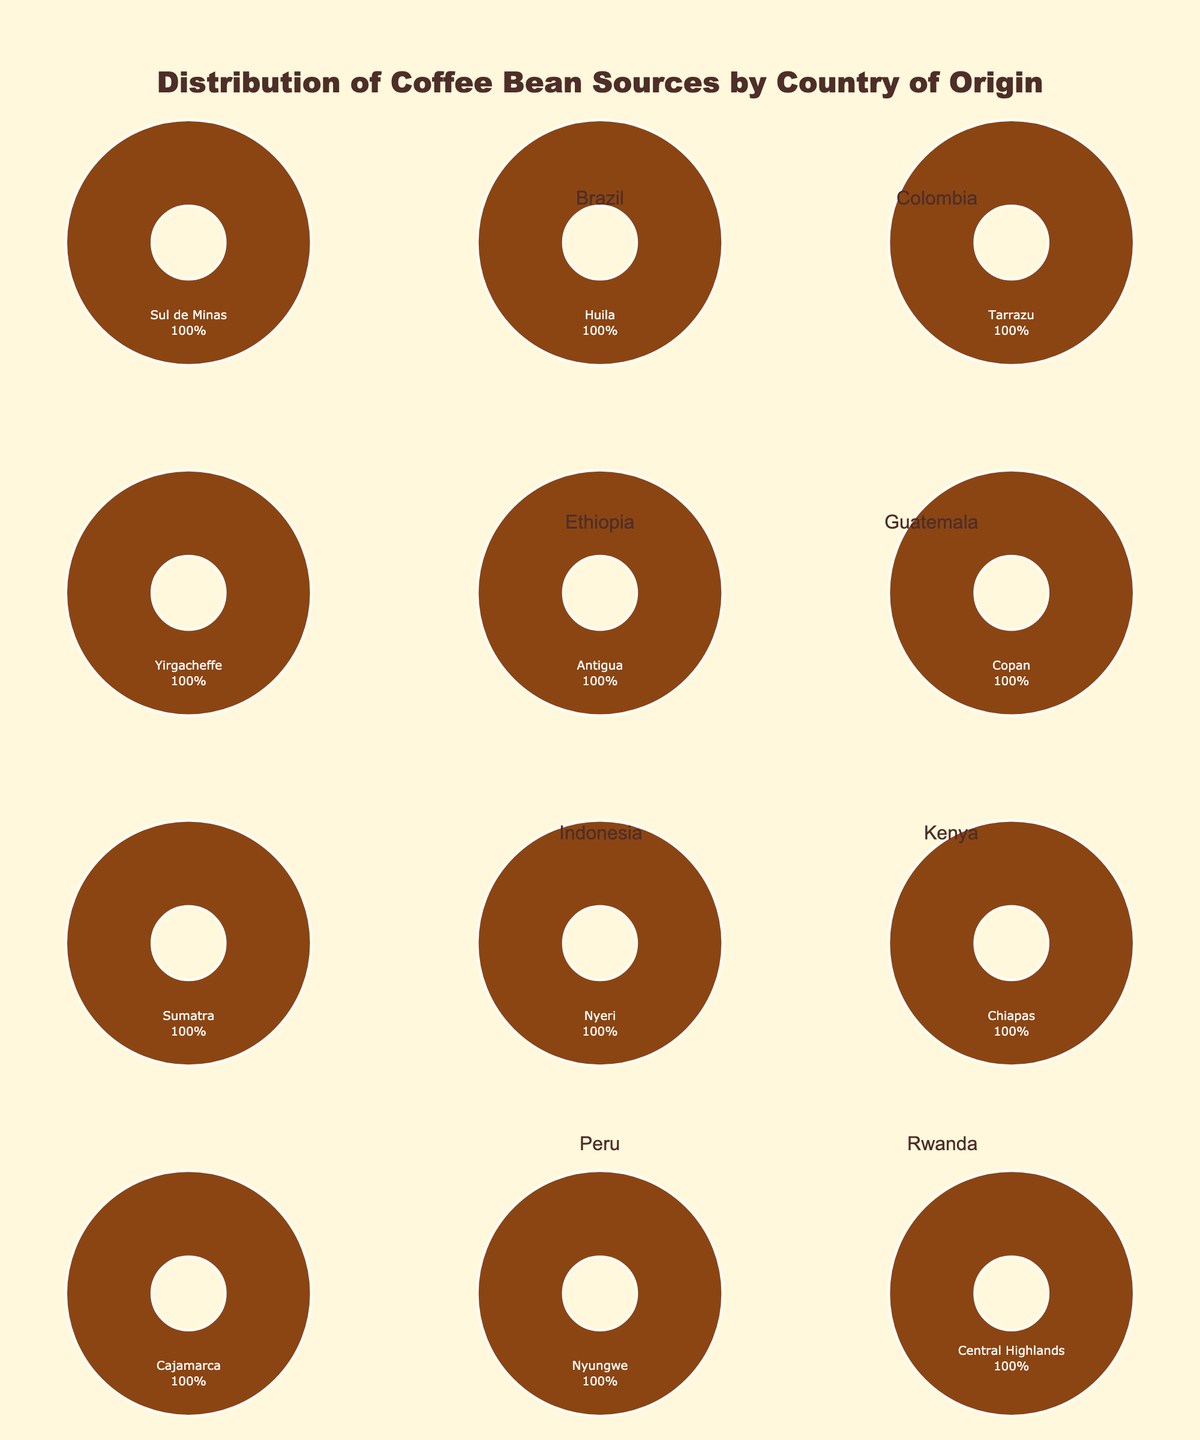Which country has the highest percentage of coffee beans sourced from a single region? Honduras has the highest percentage with 40% from Copan, according to the pie chart for Honduras.
Answer: Honduras Which two countries have an equal percentage of their coffee beans coming from a single region, and what is that percentage? Ethiopia and Kenya both have pie charts showing 20% from Yirgacheffe and Nyeri, respectively.
Answer: Ethiopia and Kenya; 20% How many countries have multiple regions contributing to their coffee bean sources? There are 4 countries with pie charts showing multiple regions contributing: Brazil, Colombia, Guatemala, and Mexico.
Answer: 4 What is the average percentage of coffee beans sourced from the 'Chiapas' region in Mexico and the 'Nyungwe' region in Rwanda? For Mexico, 'Chiapas' contributes 30% and for Rwanda, 'Nyungwe' contributes 25%. The average is (30+25)/2 = 27.5%.
Answer: 27.5% Which country has the lowest percentage contribution from a single region, and what is that percentage? The pie chart for Costa Rica shows that Tarrazu contributes the lowest at 10%.
Answer: Costa Rica; 10% Compare the total percentage of coffee beans sourced from Central America (Costa Rica, Honduras, and Guatemala). Which country has the highest total percentage? Adding up the percentages: Costa Rica (10%), Honduras (40%), and Guatemala (30%) gives totals: Costa Rica 10%, Honduras 40%, Guatemala 30%. Honduras is the highest.
Answer: Honduras Which region contributes the largest percentage to Peru's coffee beans? The pie chart for Peru shows that Cajamarca region contributes 45%.
Answer: Cajamarca How much higher is the percentage of coffee beans from 'Sul de Minas' in Brazil compared to 'Sumatra' in Indonesia? The pie chart shows Sul de Minas has 35% and Sumatra has 10%. So, the difference is 35% - 10% = 25%.
Answer: 25% What is the combined percentage of coffee beans sourced from Ethiopia and Kenya? Ethiopia's Yirgacheffe contributes 20% and Kenya’s Nyeri contributes 20%, making a combined percentage of 20% + 20% = 40%.
Answer: 40% Which country, on the pie charts, indicates a single coffee bean source with the most diverse palette of colors? Brazil, with regions showing multiple diverse colors in its pie chart.
Answer: Brazil 